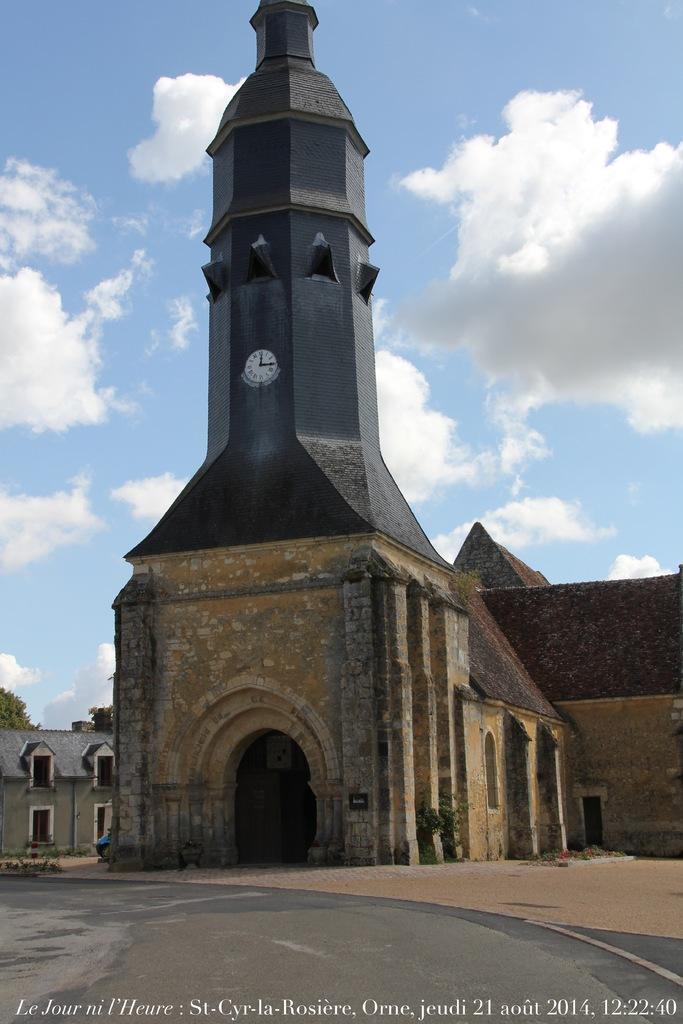How would you summarize this image in a sentence or two? In this image there is a building as we can see in middle of this image. There is one clock attached to the tower of this building, and there is a cloudy sky in the background and there is a text written at bottom of this image. 